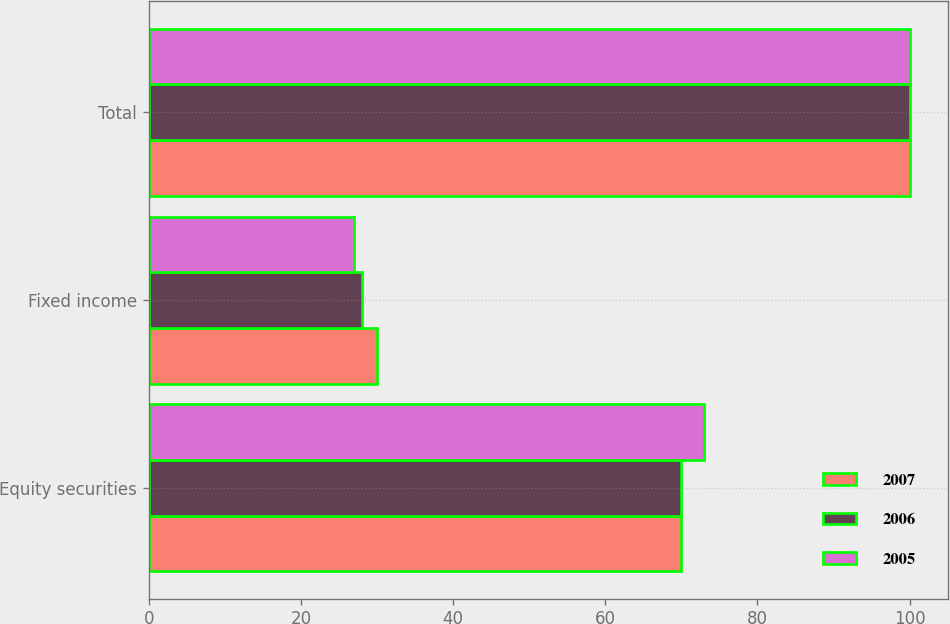Convert chart. <chart><loc_0><loc_0><loc_500><loc_500><stacked_bar_chart><ecel><fcel>Equity securities<fcel>Fixed income<fcel>Total<nl><fcel>2007<fcel>70<fcel>30<fcel>100<nl><fcel>2006<fcel>70<fcel>28<fcel>100<nl><fcel>2005<fcel>73<fcel>27<fcel>100<nl></chart> 